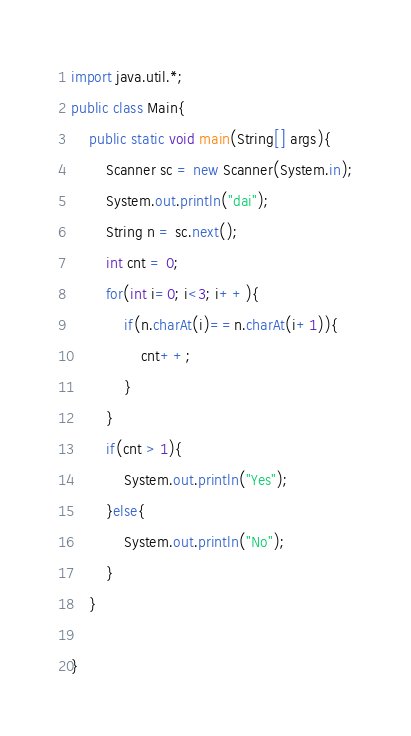<code> <loc_0><loc_0><loc_500><loc_500><_Java_>import java.util.*;
public class Main{
	public static void main(String[] args){
        Scanner sc = new Scanner(System.in);
        System.out.println("dai");
        String n = sc.next();
        int cnt = 0;
        for(int i=0; i<3; i++){
            if(n.charAt(i)==n.charAt(i+1)){
                cnt++;
            }
        }
        if(cnt > 1){
            System.out.println("Yes");
        }else{
            System.out.println("No");
        }
    }
    
}</code> 